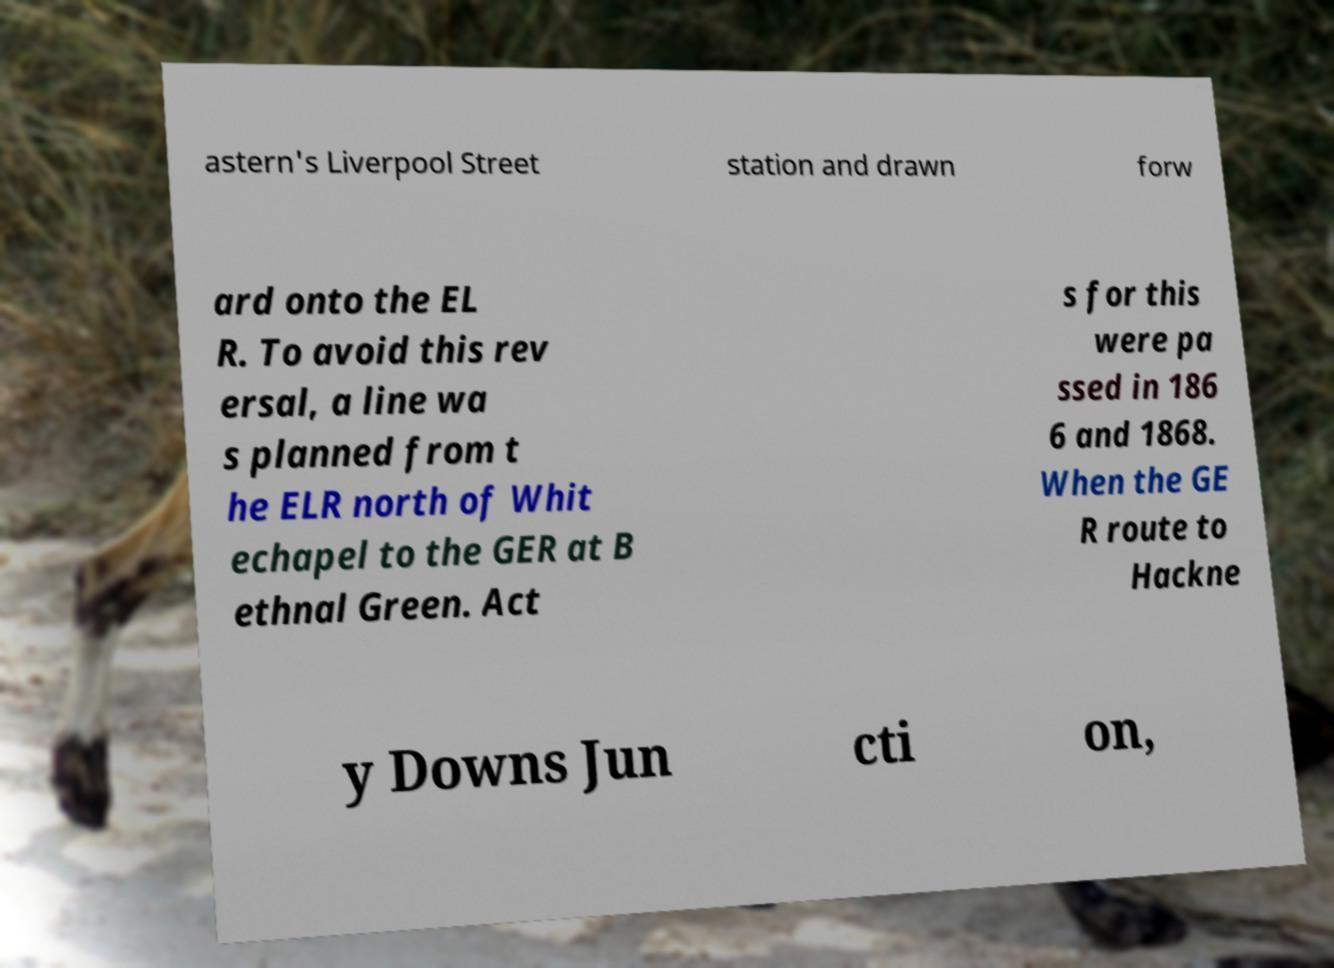What messages or text are displayed in this image? I need them in a readable, typed format. astern's Liverpool Street station and drawn forw ard onto the EL R. To avoid this rev ersal, a line wa s planned from t he ELR north of Whit echapel to the GER at B ethnal Green. Act s for this were pa ssed in 186 6 and 1868. When the GE R route to Hackne y Downs Jun cti on, 